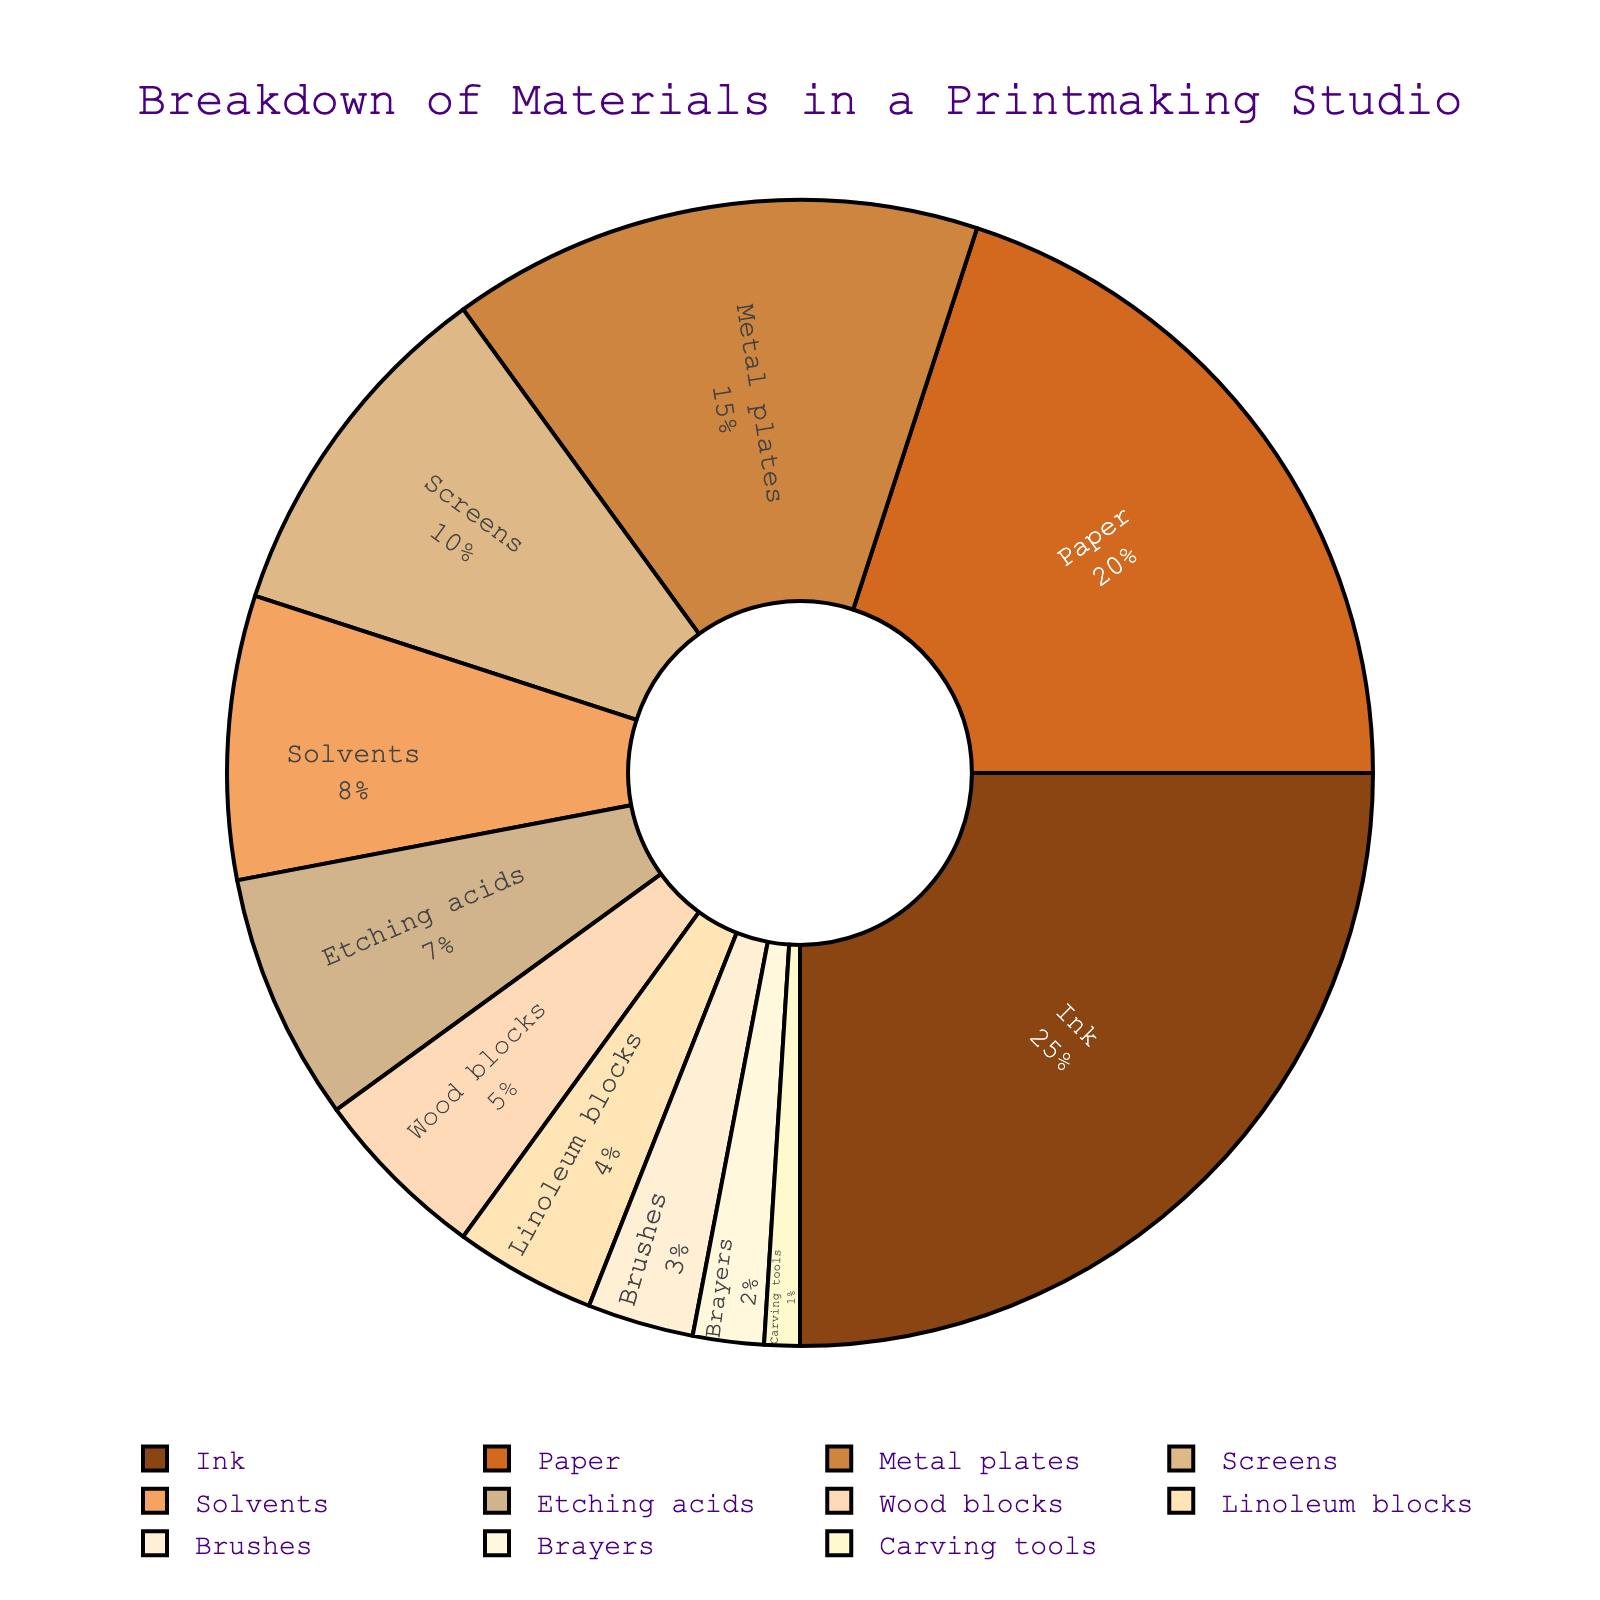Which material contributes the most to the materials used in a printmaking studio? Look for the material with the highest percentage shown in the pie chart. The material "Ink" has the highest percentage of 25%.
Answer: Ink Which two materials combined make up 35% of the materials used? Identify percentages to find two that sum to 35%. The materials "Paper" and "Metal plates" have percentages of 20% and 15% respectively, which sum to 35%.
Answer: Paper, Metal plates Are there more materials used above 10% or below 10%? Count the materials in the chart, then categorize them by percentages above and below 10%. "Ink" (25%), "Paper" (20%), "Metal plates" (15%), and "Screens" (10%) are above; the rest are below. There are 4 materials above and 7 materials below.
Answer: Below 10% Which material is represented by the smallest portion of the chart? Find the material with the smallest percentage. "Carving tools" has the smallest portion with 1%.
Answer: Carving tools By how much is the percentage of Ink greater than the percentage of Paper? Subtract Paper's percentage from Ink's percentage (25% - 20%).
Answer: 5% Which color represents the material with the second smallest percentage? Determine the material with the second smallest percentage, which is "Brayers" (2%), and identify its color. On the chart, Brayers corresponds to a shade of yellow.
Answer: Yellow How much of the material composition do "Solvents" and "Etching acids" collectively account for? Add the percentages of Solvents and Etching acids (8% + 7%).
Answer: 15% Is the percentage for "Wood blocks" closer to "Screens" or "Linoleum blocks"? Compare the percentages: Wood blocks (5%), Screens (10%), Linoleum blocks (4%). Wood blocks are closer to Linoleum blocks.
Answer: Linoleum blocks Which two materials have the same color palette and what are their percentages? Identify two materials with similar shading, then compare their percentages. "Paper" and "Brushes" both use brown shades; Paper has 20% and Brushes have 3%.
Answer: Paper (20%), Brushes (3%) 